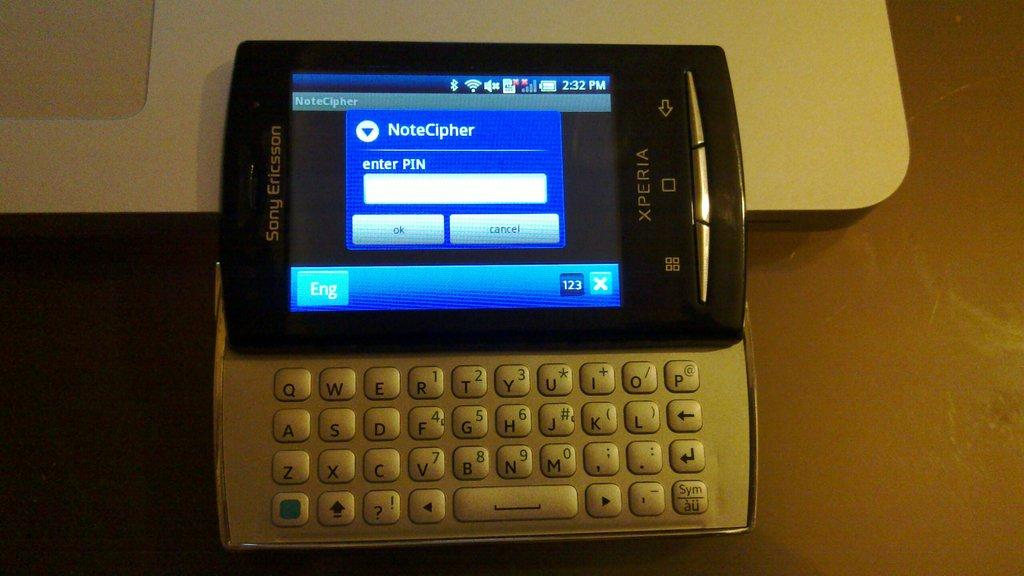<image>
Create a compact narrative representing the image presented. The brand of mobile phone is a Sony Ericsson 